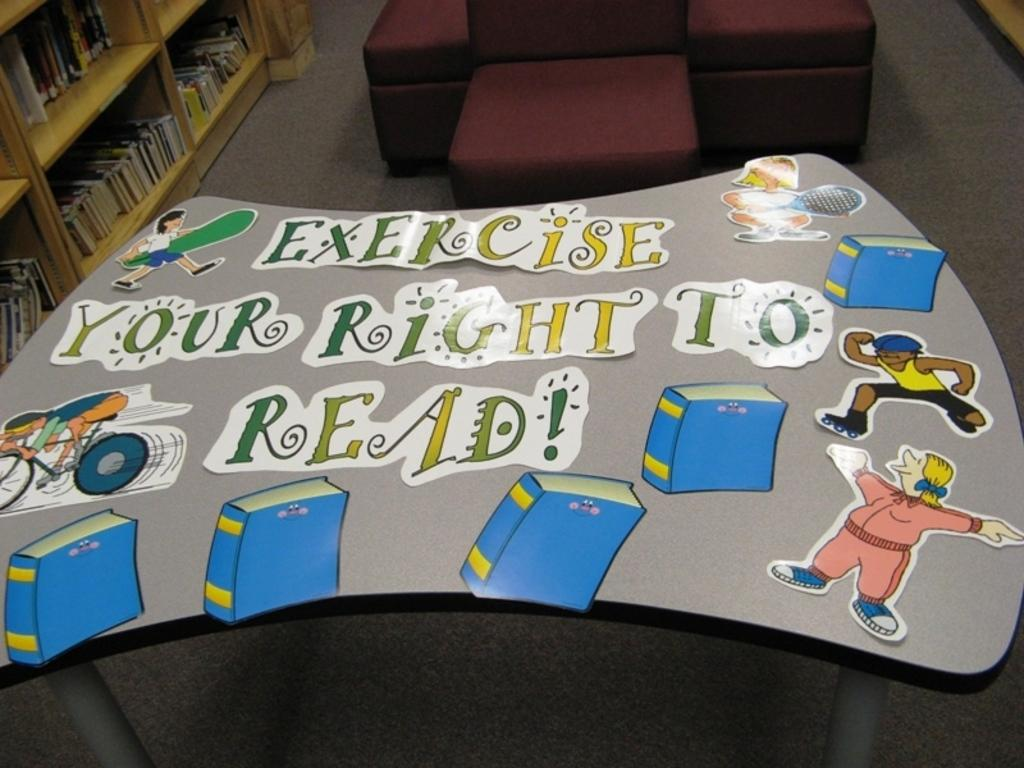<image>
Summarize the visual content of the image. Board that has the phrase which says "Exercise your right to read". 